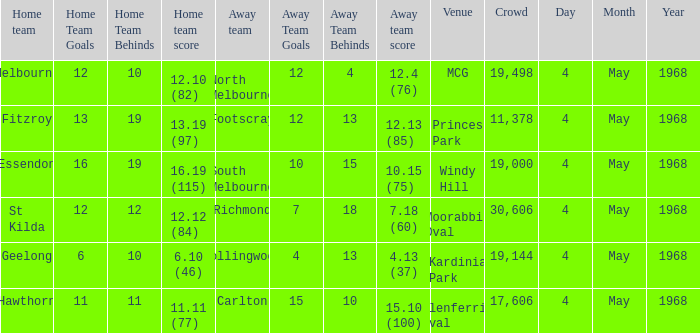What team played at Moorabbin Oval to a crowd of 19,144? St Kilda. 